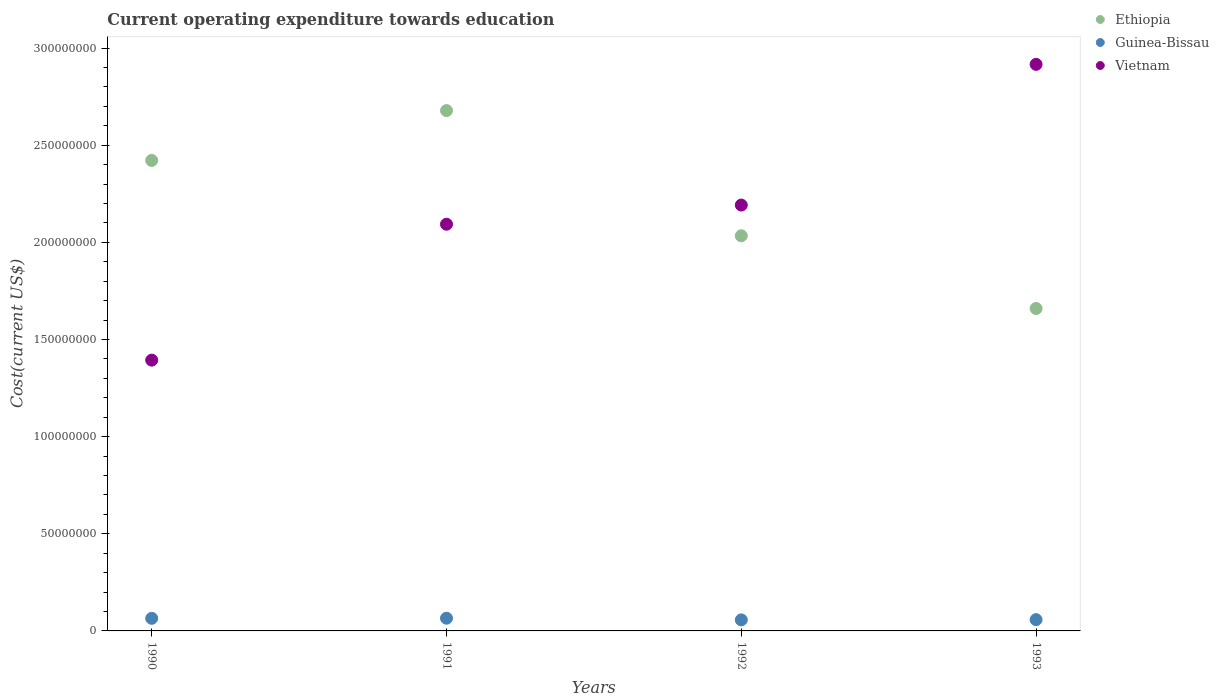How many different coloured dotlines are there?
Provide a succinct answer. 3. Is the number of dotlines equal to the number of legend labels?
Ensure brevity in your answer.  Yes. What is the expenditure towards education in Ethiopia in 1991?
Offer a terse response. 2.68e+08. Across all years, what is the maximum expenditure towards education in Ethiopia?
Your answer should be compact. 2.68e+08. Across all years, what is the minimum expenditure towards education in Vietnam?
Give a very brief answer. 1.39e+08. What is the total expenditure towards education in Guinea-Bissau in the graph?
Offer a very short reply. 2.45e+07. What is the difference between the expenditure towards education in Vietnam in 1990 and that in 1991?
Your answer should be compact. -7.00e+07. What is the difference between the expenditure towards education in Ethiopia in 1991 and the expenditure towards education in Guinea-Bissau in 1992?
Your response must be concise. 2.62e+08. What is the average expenditure towards education in Ethiopia per year?
Give a very brief answer. 2.20e+08. In the year 1991, what is the difference between the expenditure towards education in Ethiopia and expenditure towards education in Guinea-Bissau?
Keep it short and to the point. 2.61e+08. What is the ratio of the expenditure towards education in Ethiopia in 1990 to that in 1991?
Keep it short and to the point. 0.9. Is the expenditure towards education in Guinea-Bissau in 1992 less than that in 1993?
Your response must be concise. Yes. What is the difference between the highest and the second highest expenditure towards education in Vietnam?
Give a very brief answer. 7.24e+07. What is the difference between the highest and the lowest expenditure towards education in Vietnam?
Keep it short and to the point. 1.52e+08. In how many years, is the expenditure towards education in Guinea-Bissau greater than the average expenditure towards education in Guinea-Bissau taken over all years?
Your answer should be compact. 2. Is it the case that in every year, the sum of the expenditure towards education in Ethiopia and expenditure towards education in Guinea-Bissau  is greater than the expenditure towards education in Vietnam?
Offer a very short reply. No. Does the expenditure towards education in Ethiopia monotonically increase over the years?
Provide a short and direct response. No. Is the expenditure towards education in Guinea-Bissau strictly greater than the expenditure towards education in Ethiopia over the years?
Offer a terse response. No. Is the expenditure towards education in Vietnam strictly less than the expenditure towards education in Ethiopia over the years?
Keep it short and to the point. No. How many dotlines are there?
Offer a terse response. 3. How many years are there in the graph?
Keep it short and to the point. 4. Are the values on the major ticks of Y-axis written in scientific E-notation?
Your response must be concise. No. What is the title of the graph?
Keep it short and to the point. Current operating expenditure towards education. Does "India" appear as one of the legend labels in the graph?
Make the answer very short. No. What is the label or title of the Y-axis?
Your answer should be compact. Cost(current US$). What is the Cost(current US$) in Ethiopia in 1990?
Provide a succinct answer. 2.42e+08. What is the Cost(current US$) of Guinea-Bissau in 1990?
Your response must be concise. 6.48e+06. What is the Cost(current US$) of Vietnam in 1990?
Your answer should be very brief. 1.39e+08. What is the Cost(current US$) in Ethiopia in 1991?
Your answer should be very brief. 2.68e+08. What is the Cost(current US$) in Guinea-Bissau in 1991?
Your response must be concise. 6.54e+06. What is the Cost(current US$) in Vietnam in 1991?
Give a very brief answer. 2.09e+08. What is the Cost(current US$) in Ethiopia in 1992?
Ensure brevity in your answer.  2.03e+08. What is the Cost(current US$) in Guinea-Bissau in 1992?
Ensure brevity in your answer.  5.68e+06. What is the Cost(current US$) of Vietnam in 1992?
Offer a very short reply. 2.19e+08. What is the Cost(current US$) in Ethiopia in 1993?
Your answer should be compact. 1.66e+08. What is the Cost(current US$) of Guinea-Bissau in 1993?
Provide a short and direct response. 5.80e+06. What is the Cost(current US$) of Vietnam in 1993?
Give a very brief answer. 2.92e+08. Across all years, what is the maximum Cost(current US$) of Ethiopia?
Your answer should be very brief. 2.68e+08. Across all years, what is the maximum Cost(current US$) in Guinea-Bissau?
Your answer should be very brief. 6.54e+06. Across all years, what is the maximum Cost(current US$) of Vietnam?
Offer a terse response. 2.92e+08. Across all years, what is the minimum Cost(current US$) of Ethiopia?
Keep it short and to the point. 1.66e+08. Across all years, what is the minimum Cost(current US$) of Guinea-Bissau?
Offer a terse response. 5.68e+06. Across all years, what is the minimum Cost(current US$) of Vietnam?
Offer a terse response. 1.39e+08. What is the total Cost(current US$) in Ethiopia in the graph?
Give a very brief answer. 8.79e+08. What is the total Cost(current US$) in Guinea-Bissau in the graph?
Offer a very short reply. 2.45e+07. What is the total Cost(current US$) of Vietnam in the graph?
Make the answer very short. 8.59e+08. What is the difference between the Cost(current US$) of Ethiopia in 1990 and that in 1991?
Your response must be concise. -2.56e+07. What is the difference between the Cost(current US$) of Guinea-Bissau in 1990 and that in 1991?
Offer a terse response. -6.25e+04. What is the difference between the Cost(current US$) in Vietnam in 1990 and that in 1991?
Make the answer very short. -7.00e+07. What is the difference between the Cost(current US$) of Ethiopia in 1990 and that in 1992?
Your response must be concise. 3.88e+07. What is the difference between the Cost(current US$) in Guinea-Bissau in 1990 and that in 1992?
Provide a short and direct response. 7.95e+05. What is the difference between the Cost(current US$) of Vietnam in 1990 and that in 1992?
Your answer should be very brief. -7.98e+07. What is the difference between the Cost(current US$) of Ethiopia in 1990 and that in 1993?
Your answer should be compact. 7.62e+07. What is the difference between the Cost(current US$) in Guinea-Bissau in 1990 and that in 1993?
Provide a short and direct response. 6.78e+05. What is the difference between the Cost(current US$) in Vietnam in 1990 and that in 1993?
Keep it short and to the point. -1.52e+08. What is the difference between the Cost(current US$) in Ethiopia in 1991 and that in 1992?
Provide a succinct answer. 6.44e+07. What is the difference between the Cost(current US$) of Guinea-Bissau in 1991 and that in 1992?
Give a very brief answer. 8.57e+05. What is the difference between the Cost(current US$) in Vietnam in 1991 and that in 1992?
Offer a terse response. -9.86e+06. What is the difference between the Cost(current US$) in Ethiopia in 1991 and that in 1993?
Offer a terse response. 1.02e+08. What is the difference between the Cost(current US$) in Guinea-Bissau in 1991 and that in 1993?
Your answer should be compact. 7.40e+05. What is the difference between the Cost(current US$) in Vietnam in 1991 and that in 1993?
Provide a short and direct response. -8.23e+07. What is the difference between the Cost(current US$) of Ethiopia in 1992 and that in 1993?
Offer a very short reply. 3.74e+07. What is the difference between the Cost(current US$) of Guinea-Bissau in 1992 and that in 1993?
Offer a very short reply. -1.17e+05. What is the difference between the Cost(current US$) in Vietnam in 1992 and that in 1993?
Provide a succinct answer. -7.24e+07. What is the difference between the Cost(current US$) of Ethiopia in 1990 and the Cost(current US$) of Guinea-Bissau in 1991?
Ensure brevity in your answer.  2.36e+08. What is the difference between the Cost(current US$) in Ethiopia in 1990 and the Cost(current US$) in Vietnam in 1991?
Provide a succinct answer. 3.28e+07. What is the difference between the Cost(current US$) of Guinea-Bissau in 1990 and the Cost(current US$) of Vietnam in 1991?
Offer a very short reply. -2.03e+08. What is the difference between the Cost(current US$) in Ethiopia in 1990 and the Cost(current US$) in Guinea-Bissau in 1992?
Make the answer very short. 2.36e+08. What is the difference between the Cost(current US$) of Ethiopia in 1990 and the Cost(current US$) of Vietnam in 1992?
Keep it short and to the point. 2.30e+07. What is the difference between the Cost(current US$) of Guinea-Bissau in 1990 and the Cost(current US$) of Vietnam in 1992?
Keep it short and to the point. -2.13e+08. What is the difference between the Cost(current US$) in Ethiopia in 1990 and the Cost(current US$) in Guinea-Bissau in 1993?
Your answer should be compact. 2.36e+08. What is the difference between the Cost(current US$) in Ethiopia in 1990 and the Cost(current US$) in Vietnam in 1993?
Offer a terse response. -4.94e+07. What is the difference between the Cost(current US$) in Guinea-Bissau in 1990 and the Cost(current US$) in Vietnam in 1993?
Your answer should be very brief. -2.85e+08. What is the difference between the Cost(current US$) of Ethiopia in 1991 and the Cost(current US$) of Guinea-Bissau in 1992?
Your answer should be compact. 2.62e+08. What is the difference between the Cost(current US$) of Ethiopia in 1991 and the Cost(current US$) of Vietnam in 1992?
Your answer should be very brief. 4.86e+07. What is the difference between the Cost(current US$) in Guinea-Bissau in 1991 and the Cost(current US$) in Vietnam in 1992?
Offer a terse response. -2.13e+08. What is the difference between the Cost(current US$) of Ethiopia in 1991 and the Cost(current US$) of Guinea-Bissau in 1993?
Provide a short and direct response. 2.62e+08. What is the difference between the Cost(current US$) in Ethiopia in 1991 and the Cost(current US$) in Vietnam in 1993?
Your response must be concise. -2.38e+07. What is the difference between the Cost(current US$) of Guinea-Bissau in 1991 and the Cost(current US$) of Vietnam in 1993?
Make the answer very short. -2.85e+08. What is the difference between the Cost(current US$) in Ethiopia in 1992 and the Cost(current US$) in Guinea-Bissau in 1993?
Ensure brevity in your answer.  1.98e+08. What is the difference between the Cost(current US$) in Ethiopia in 1992 and the Cost(current US$) in Vietnam in 1993?
Offer a very short reply. -8.82e+07. What is the difference between the Cost(current US$) of Guinea-Bissau in 1992 and the Cost(current US$) of Vietnam in 1993?
Give a very brief answer. -2.86e+08. What is the average Cost(current US$) in Ethiopia per year?
Offer a terse response. 2.20e+08. What is the average Cost(current US$) in Guinea-Bissau per year?
Offer a very short reply. 6.13e+06. What is the average Cost(current US$) in Vietnam per year?
Your response must be concise. 2.15e+08. In the year 1990, what is the difference between the Cost(current US$) in Ethiopia and Cost(current US$) in Guinea-Bissau?
Offer a very short reply. 2.36e+08. In the year 1990, what is the difference between the Cost(current US$) in Ethiopia and Cost(current US$) in Vietnam?
Provide a short and direct response. 1.03e+08. In the year 1990, what is the difference between the Cost(current US$) in Guinea-Bissau and Cost(current US$) in Vietnam?
Make the answer very short. -1.33e+08. In the year 1991, what is the difference between the Cost(current US$) in Ethiopia and Cost(current US$) in Guinea-Bissau?
Your answer should be very brief. 2.61e+08. In the year 1991, what is the difference between the Cost(current US$) in Ethiopia and Cost(current US$) in Vietnam?
Make the answer very short. 5.85e+07. In the year 1991, what is the difference between the Cost(current US$) in Guinea-Bissau and Cost(current US$) in Vietnam?
Keep it short and to the point. -2.03e+08. In the year 1992, what is the difference between the Cost(current US$) of Ethiopia and Cost(current US$) of Guinea-Bissau?
Your response must be concise. 1.98e+08. In the year 1992, what is the difference between the Cost(current US$) of Ethiopia and Cost(current US$) of Vietnam?
Give a very brief answer. -1.58e+07. In the year 1992, what is the difference between the Cost(current US$) in Guinea-Bissau and Cost(current US$) in Vietnam?
Ensure brevity in your answer.  -2.14e+08. In the year 1993, what is the difference between the Cost(current US$) in Ethiopia and Cost(current US$) in Guinea-Bissau?
Offer a very short reply. 1.60e+08. In the year 1993, what is the difference between the Cost(current US$) of Ethiopia and Cost(current US$) of Vietnam?
Provide a succinct answer. -1.26e+08. In the year 1993, what is the difference between the Cost(current US$) in Guinea-Bissau and Cost(current US$) in Vietnam?
Give a very brief answer. -2.86e+08. What is the ratio of the Cost(current US$) in Ethiopia in 1990 to that in 1991?
Your answer should be very brief. 0.9. What is the ratio of the Cost(current US$) of Guinea-Bissau in 1990 to that in 1991?
Ensure brevity in your answer.  0.99. What is the ratio of the Cost(current US$) of Vietnam in 1990 to that in 1991?
Offer a terse response. 0.67. What is the ratio of the Cost(current US$) of Ethiopia in 1990 to that in 1992?
Give a very brief answer. 1.19. What is the ratio of the Cost(current US$) of Guinea-Bissau in 1990 to that in 1992?
Ensure brevity in your answer.  1.14. What is the ratio of the Cost(current US$) in Vietnam in 1990 to that in 1992?
Ensure brevity in your answer.  0.64. What is the ratio of the Cost(current US$) of Ethiopia in 1990 to that in 1993?
Your response must be concise. 1.46. What is the ratio of the Cost(current US$) in Guinea-Bissau in 1990 to that in 1993?
Provide a short and direct response. 1.12. What is the ratio of the Cost(current US$) in Vietnam in 1990 to that in 1993?
Ensure brevity in your answer.  0.48. What is the ratio of the Cost(current US$) of Ethiopia in 1991 to that in 1992?
Provide a short and direct response. 1.32. What is the ratio of the Cost(current US$) in Guinea-Bissau in 1991 to that in 1992?
Your answer should be compact. 1.15. What is the ratio of the Cost(current US$) in Vietnam in 1991 to that in 1992?
Ensure brevity in your answer.  0.95. What is the ratio of the Cost(current US$) of Ethiopia in 1991 to that in 1993?
Provide a short and direct response. 1.61. What is the ratio of the Cost(current US$) in Guinea-Bissau in 1991 to that in 1993?
Keep it short and to the point. 1.13. What is the ratio of the Cost(current US$) of Vietnam in 1991 to that in 1993?
Your response must be concise. 0.72. What is the ratio of the Cost(current US$) in Ethiopia in 1992 to that in 1993?
Your answer should be compact. 1.23. What is the ratio of the Cost(current US$) of Guinea-Bissau in 1992 to that in 1993?
Provide a succinct answer. 0.98. What is the ratio of the Cost(current US$) in Vietnam in 1992 to that in 1993?
Your response must be concise. 0.75. What is the difference between the highest and the second highest Cost(current US$) of Ethiopia?
Offer a very short reply. 2.56e+07. What is the difference between the highest and the second highest Cost(current US$) in Guinea-Bissau?
Your answer should be very brief. 6.25e+04. What is the difference between the highest and the second highest Cost(current US$) of Vietnam?
Provide a succinct answer. 7.24e+07. What is the difference between the highest and the lowest Cost(current US$) in Ethiopia?
Your answer should be very brief. 1.02e+08. What is the difference between the highest and the lowest Cost(current US$) of Guinea-Bissau?
Your response must be concise. 8.57e+05. What is the difference between the highest and the lowest Cost(current US$) in Vietnam?
Provide a succinct answer. 1.52e+08. 